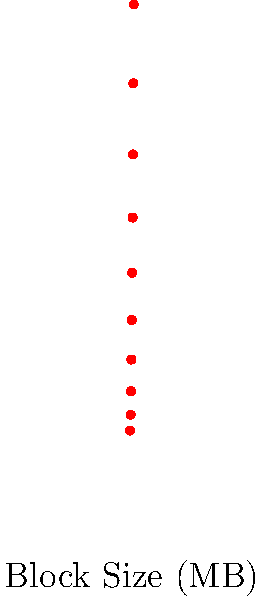Based on the scatter plot showing the relationship between block size and network latency in a blockchain network, what can be inferred about the scalability challenge as block sizes increase? How would you quantify this relationship, and what implications does it have for improving blockchain scalability? To analyze the relationship between block size and network latency:

1. Observe the trend: The scatter plot shows a clear positive correlation between block size and network latency.

2. Quantify the relationship: The trend appears to be roughly linear. We can estimate the relationship using a linear regression model:

   Latency ≈ 80 + 110 * BlockSize

3. Interpret the slope: For each 1 MB increase in block size, we expect about 110 ms increase in network latency.

4. Scalability implications:
   a) As block size increases, network latency grows significantly.
   b) This presents a scalability challenge: larger blocks can increase throughput but at the cost of higher latency.
   c) The trade-off between block size and latency needs to be carefully managed.

5. Potential solutions:
   a) Optimize network protocols to reduce latency growth rate.
   b) Implement sharding or layer-2 solutions to process transactions off the main chain.
   c) Develop adaptive block size mechanisms based on network conditions.

6. Data science approach:
   a) Use regression analysis to model the relationship more precisely.
   b) Employ time series analysis to study how this relationship changes over time.
   c) Utilize machine learning to predict optimal block sizes based on network conditions.

The analysis suggests that simply increasing block size is not a sustainable solution for improving blockchain scalability due to the associated increase in network latency.
Answer: Increasing block size leads to higher network latency (≈110 ms/MB), indicating a significant scalability challenge that requires advanced solutions beyond simple block size increases. 